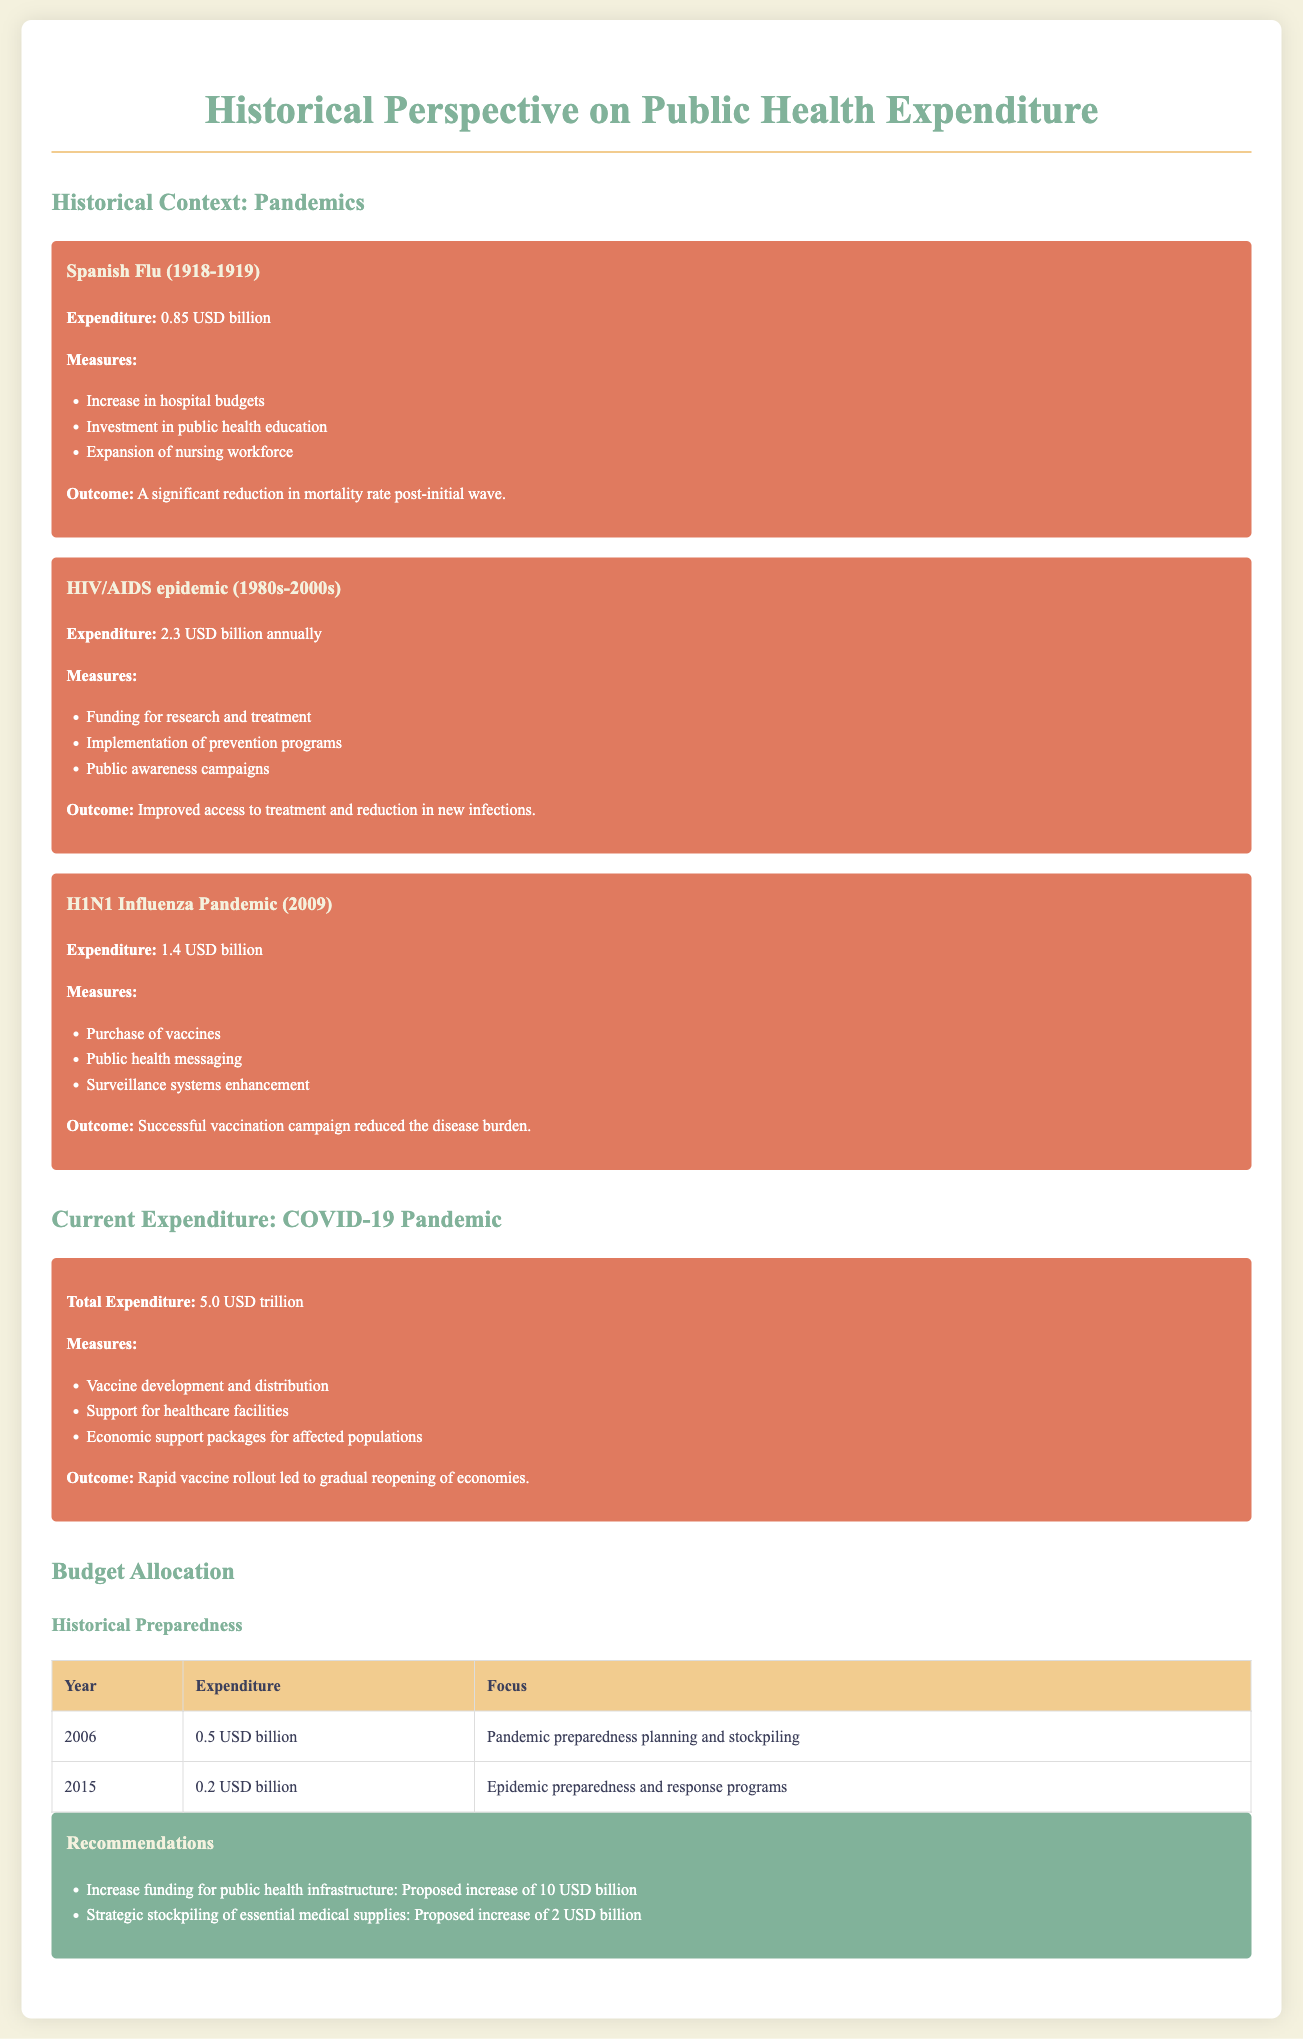what was the expenditure for the Spanish Flu? The expenditure for the Spanish Flu was explicitly stated in the document as 0.85 billion USD.
Answer: 0.85 billion USD how much was allocated for pandemic preparedness planning in 2006? The document states that 0.5 billion USD was spent on pandemic preparedness planning in 2006.
Answer: 0.5 billion USD what was a significant outcome of the HIV/AIDS epidemic measures? The document indicates that the outcome of the HIV/AIDS epidemic measures was improved access to treatment and reduction in new infections.
Answer: Improved access to treatment and reduction in new infections what is the total expenditure for COVID-19? The total expenditure for COVID-19 is stated in the document as 5.0 trillion USD.
Answer: 5.0 trillion USD how much funding is proposed to increase public health infrastructure? According to the recommendations, there is a proposed increase of 10 billion USD for public health infrastructure.
Answer: 10 billion USD what was one of the measures taken during the H1N1 Influenza Pandemic? The document mentions that one measure taken during the H1N1 pandemic was the purchase of vaccines.
Answer: Purchase of vaccines what was the focus of budget allocation in 2015? The document lists that the focus of budget allocation in 2015 was on epidemic preparedness and response programs.
Answer: Epidemic preparedness and response programs what type of campaigns were part of the measures during the HIV/AIDS epidemic? The document notes that public awareness campaigns were part of the measures during the HIV/AIDS epidemic.
Answer: Public awareness campaigns what outcome was achieved from the COVID-19 vaccine rollout? The outcome achieved from the COVID-19 vaccine rollout was a gradual reopening of economies.
Answer: Gradual reopening of economies 